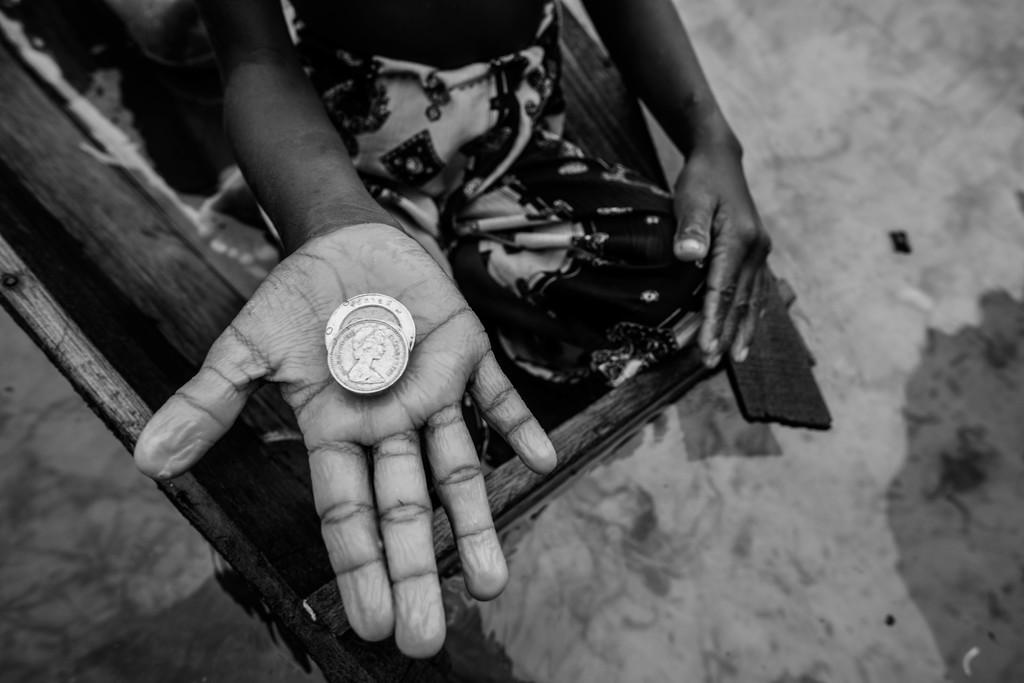What is the color scheme of the image? The image is black and white. What can be seen on the person's hand in the image? There are two coins on the person's hand in the image. What type of curtain is hanging in the background of the image? There is no curtain present in the image; it is a black and white image with two coins on a person's hand. 